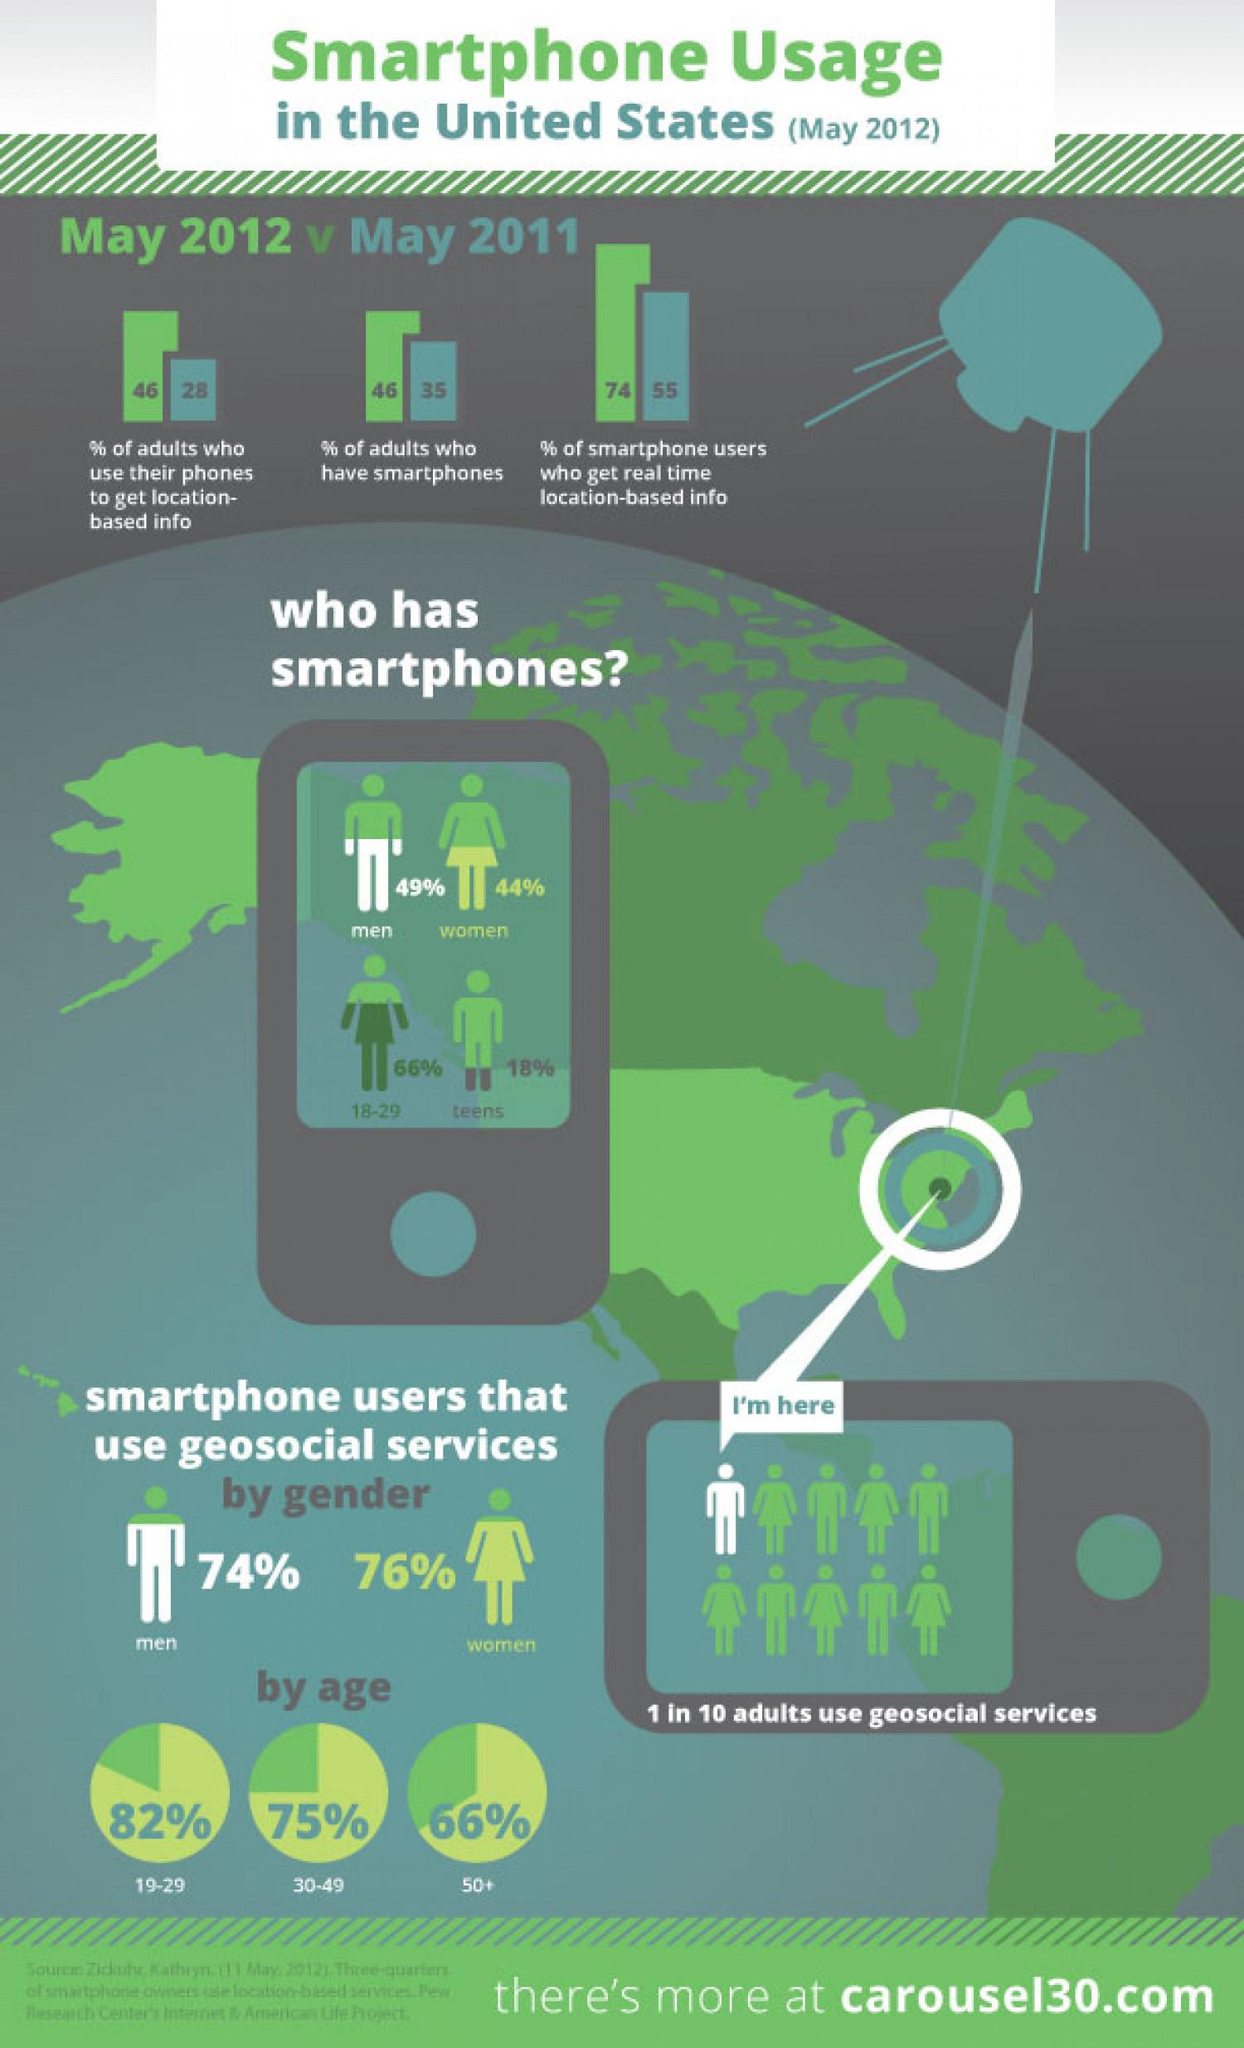Highlight a few significant elements in this photo. The second highest age group of smartphone users utilizing geo-social services are those between the ages of 30 and 49. A recent survey revealed that 49% of men own smartphones. The percentage of adults who owned smartphones increased by [X]% from May 2011 to May 2012. It is estimated that 76% of females use smartphone geosocial services. According to recent data, approximately 10% of adults use geosocial services. 